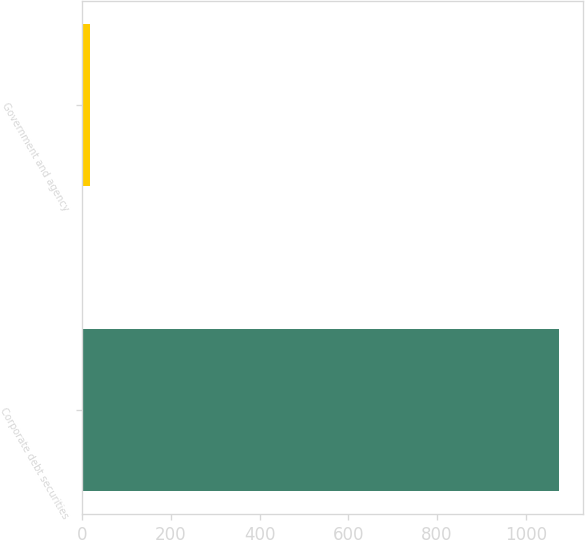<chart> <loc_0><loc_0><loc_500><loc_500><bar_chart><fcel>Corporate debt securities<fcel>Government and agency<nl><fcel>1075<fcel>17<nl></chart> 